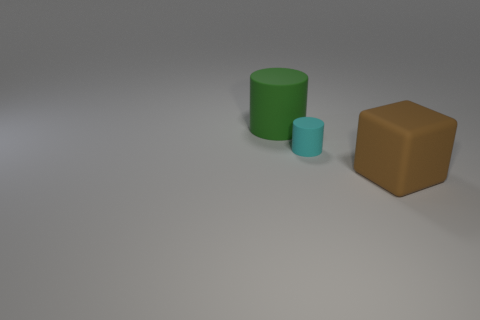Add 2 large cylinders. How many objects exist? 5 Subtract all cylinders. How many objects are left? 1 Subtract all blue shiny blocks. Subtract all tiny rubber things. How many objects are left? 2 Add 2 large brown things. How many large brown things are left? 3 Add 1 green metal cubes. How many green metal cubes exist? 1 Subtract 0 gray spheres. How many objects are left? 3 